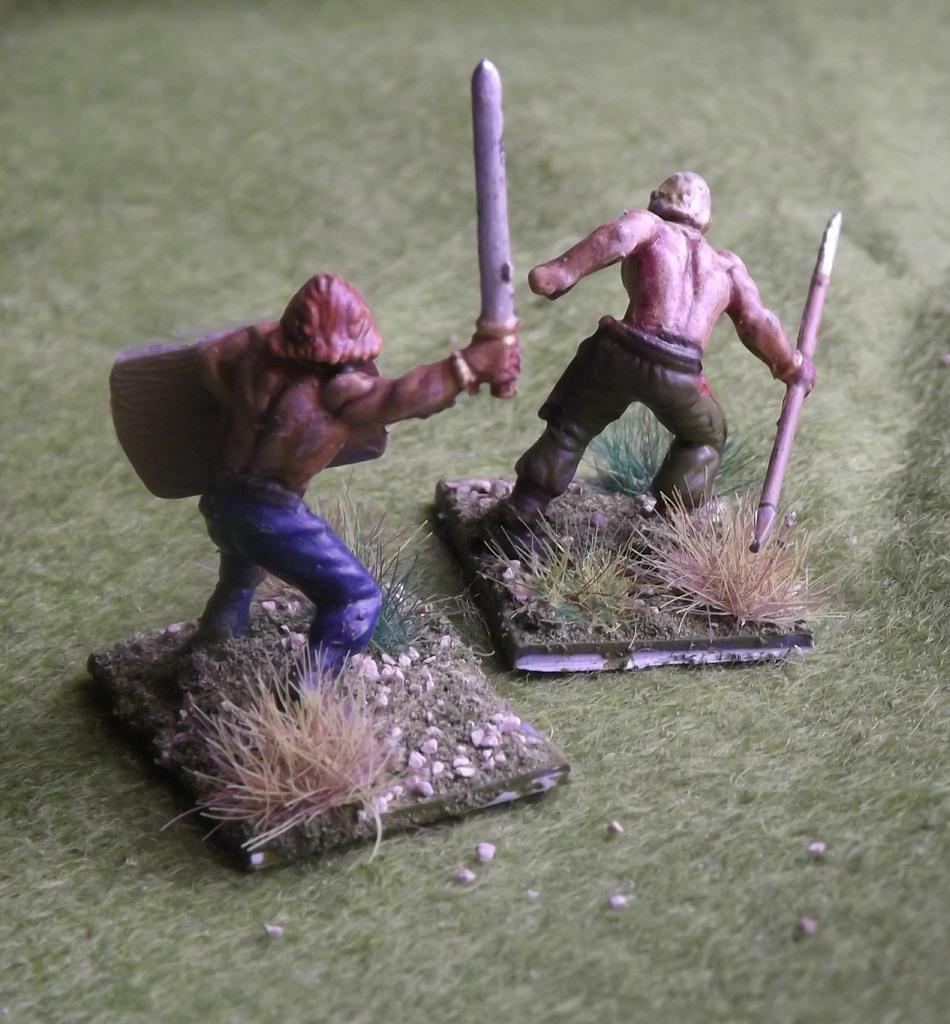How many toys can be seen in the image? There are two toys in the image. What type of natural environment is present in the image? There is grass in the image. What other objects can be seen in the image besides the toys? There are stones in the image. On what surface are the toys and other objects placed? The objects are on a mat. Can you see any planes flying over the grass in the image? No, there are no planes visible in the image. Is there any meat being served on the mat in the image? No, there is no meat present in the image. 